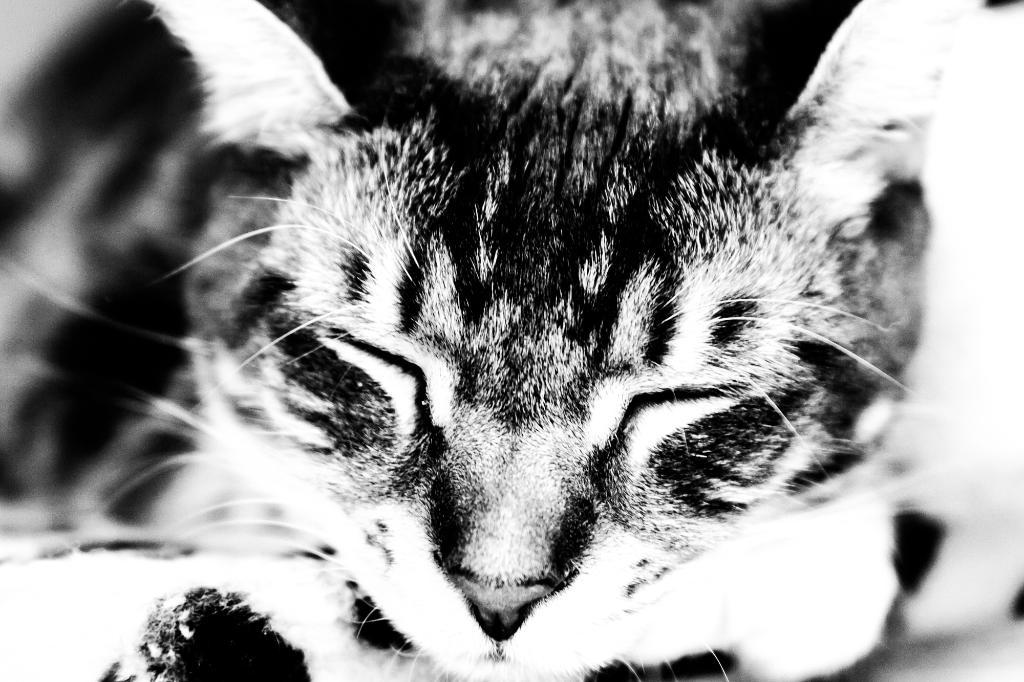What is the color scheme of the image? The image is black and white. What is the main subject of the image? There is a picture of a cat in the image. Is there a chair visible in the image? There is no chair present in the image; it only features a picture of a cat. Can you see any steam coming from the cat in the image? There is no steam present in the image; it is a black and white picture of a cat. 